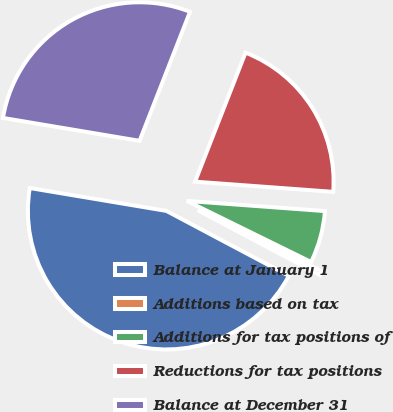Convert chart to OTSL. <chart><loc_0><loc_0><loc_500><loc_500><pie_chart><fcel>Balance at January 1<fcel>Additions based on tax<fcel>Additions for tax positions of<fcel>Reductions for tax positions<fcel>Balance at December 31<nl><fcel>44.88%<fcel>0.49%<fcel>6.1%<fcel>20.24%<fcel>28.29%<nl></chart> 